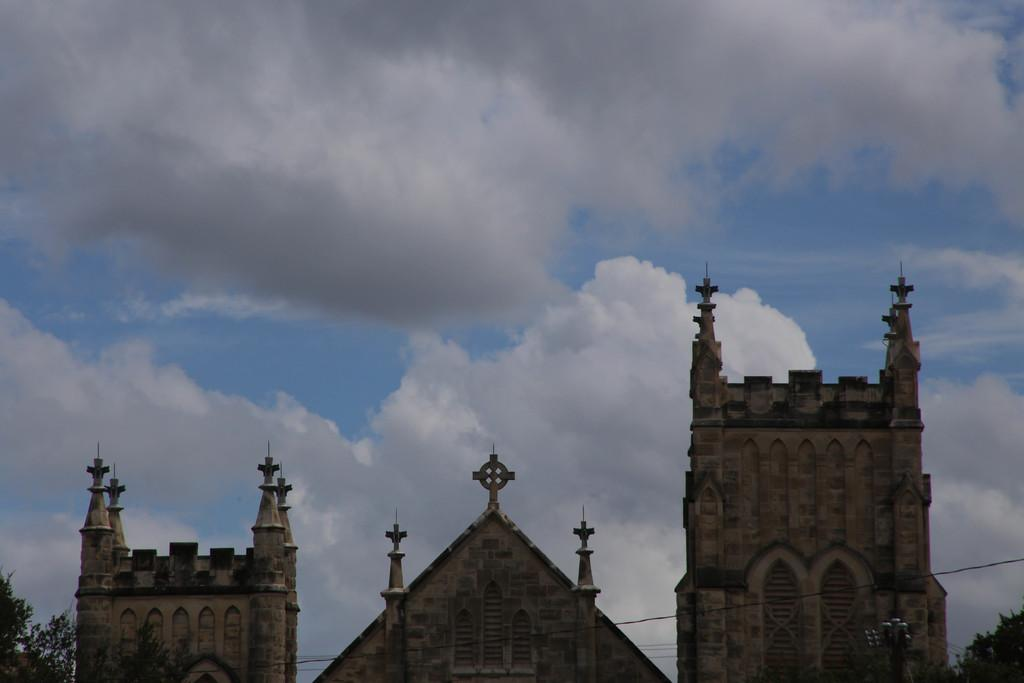What type of structures can be seen in the image? There are buildings in the image. What else is present in the image besides the buildings? There are wires and trees visible in the image. What is visible in the background of the image? The sky is visible in the background of the image. What type of recess can be seen in the image? There is no recess present in the image. What type of ray is visible in the image? There is no ray visible in the image. 